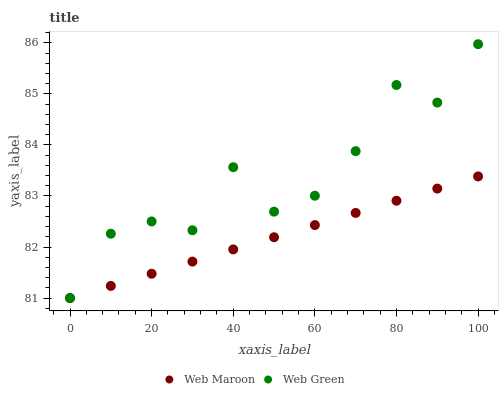Does Web Maroon have the minimum area under the curve?
Answer yes or no. Yes. Does Web Green have the maximum area under the curve?
Answer yes or no. Yes. Does Web Green have the minimum area under the curve?
Answer yes or no. No. Is Web Maroon the smoothest?
Answer yes or no. Yes. Is Web Green the roughest?
Answer yes or no. Yes. Is Web Green the smoothest?
Answer yes or no. No. Does Web Maroon have the lowest value?
Answer yes or no. Yes. Does Web Green have the highest value?
Answer yes or no. Yes. Does Web Green intersect Web Maroon?
Answer yes or no. Yes. Is Web Green less than Web Maroon?
Answer yes or no. No. Is Web Green greater than Web Maroon?
Answer yes or no. No. 